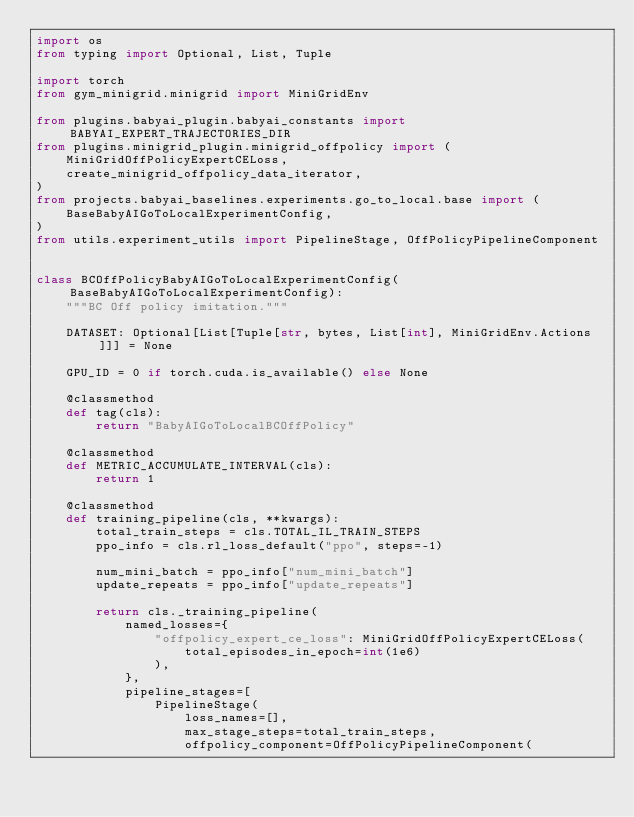<code> <loc_0><loc_0><loc_500><loc_500><_Python_>import os
from typing import Optional, List, Tuple

import torch
from gym_minigrid.minigrid import MiniGridEnv

from plugins.babyai_plugin.babyai_constants import BABYAI_EXPERT_TRAJECTORIES_DIR
from plugins.minigrid_plugin.minigrid_offpolicy import (
    MiniGridOffPolicyExpertCELoss,
    create_minigrid_offpolicy_data_iterator,
)
from projects.babyai_baselines.experiments.go_to_local.base import (
    BaseBabyAIGoToLocalExperimentConfig,
)
from utils.experiment_utils import PipelineStage, OffPolicyPipelineComponent


class BCOffPolicyBabyAIGoToLocalExperimentConfig(BaseBabyAIGoToLocalExperimentConfig):
    """BC Off policy imitation."""

    DATASET: Optional[List[Tuple[str, bytes, List[int], MiniGridEnv.Actions]]] = None

    GPU_ID = 0 if torch.cuda.is_available() else None

    @classmethod
    def tag(cls):
        return "BabyAIGoToLocalBCOffPolicy"

    @classmethod
    def METRIC_ACCUMULATE_INTERVAL(cls):
        return 1

    @classmethod
    def training_pipeline(cls, **kwargs):
        total_train_steps = cls.TOTAL_IL_TRAIN_STEPS
        ppo_info = cls.rl_loss_default("ppo", steps=-1)

        num_mini_batch = ppo_info["num_mini_batch"]
        update_repeats = ppo_info["update_repeats"]

        return cls._training_pipeline(
            named_losses={
                "offpolicy_expert_ce_loss": MiniGridOffPolicyExpertCELoss(
                    total_episodes_in_epoch=int(1e6)
                ),
            },
            pipeline_stages=[
                PipelineStage(
                    loss_names=[],
                    max_stage_steps=total_train_steps,
                    offpolicy_component=OffPolicyPipelineComponent(</code> 